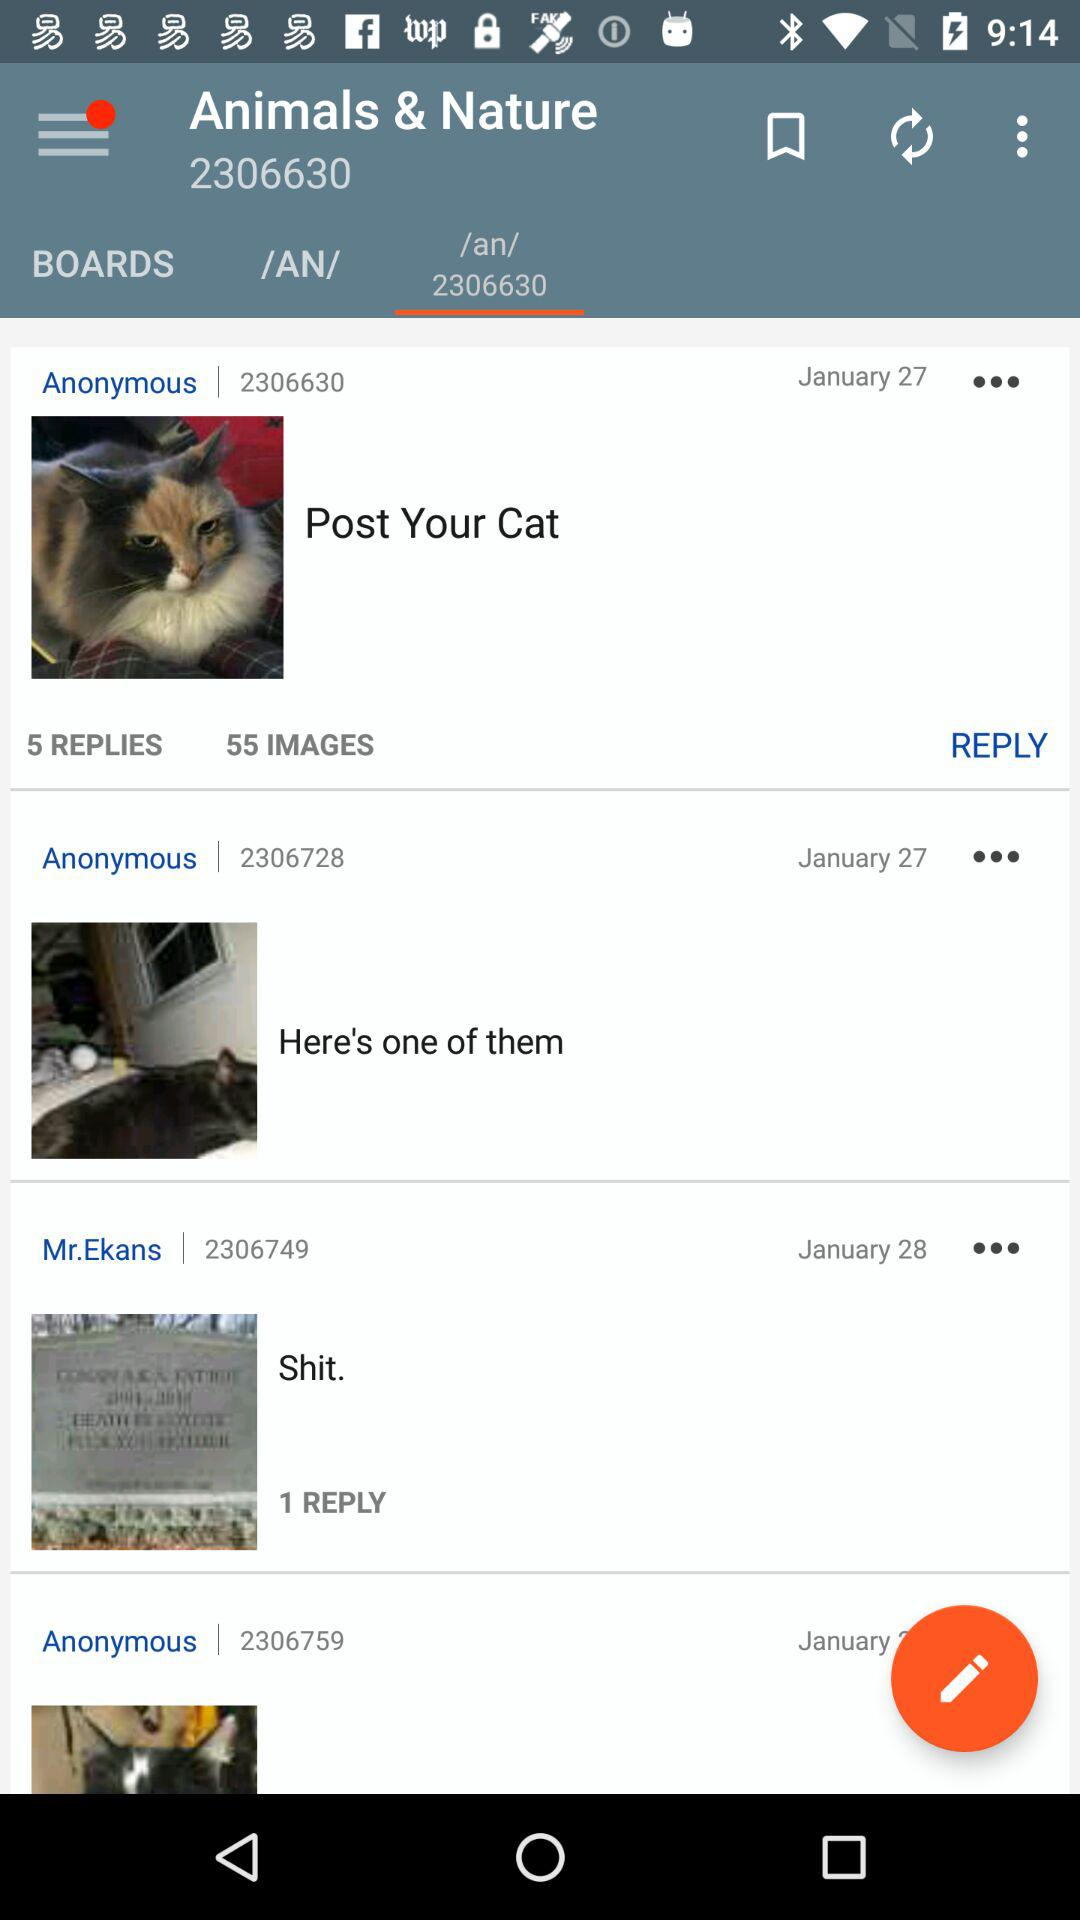How many replies are there on the post "Shit."? There is 1 reply. 